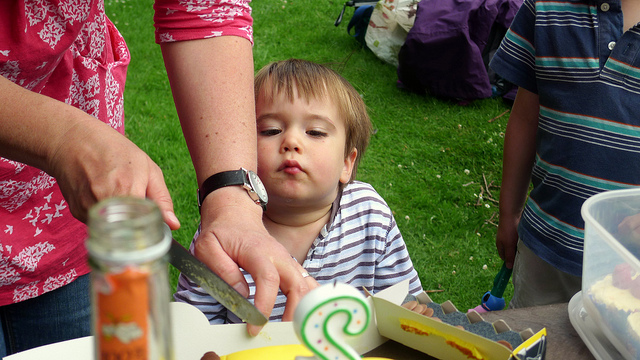How many knives can be seen? There is only one knife visible in the image, which appears to be in use, likely for preparing or serving food. 